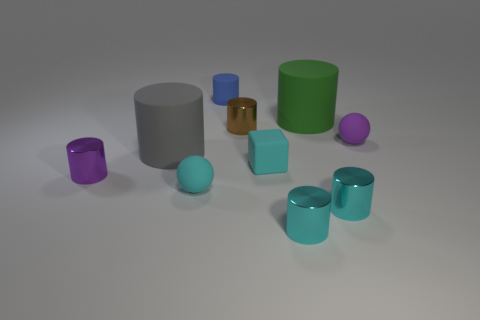How could the arrangement of these objects tell a story or convey a message? The arrangement of objects could symbolize diversity and unity; different colors and sizes represent variety, while the similar shapes convey a sense of harmony. It can be interpreted as an abstract representation of individuals in a community or team, distinct yet cohesive. 